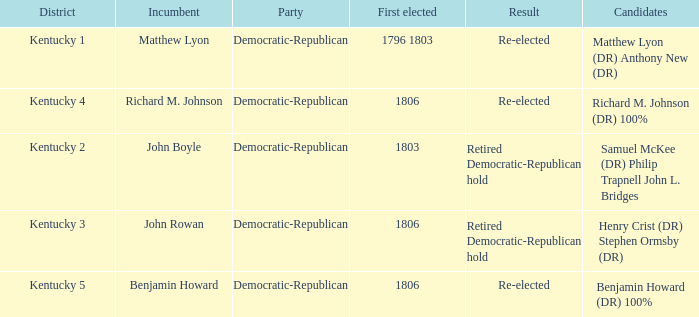Name the number of first elected for kentucky 3 1.0. 